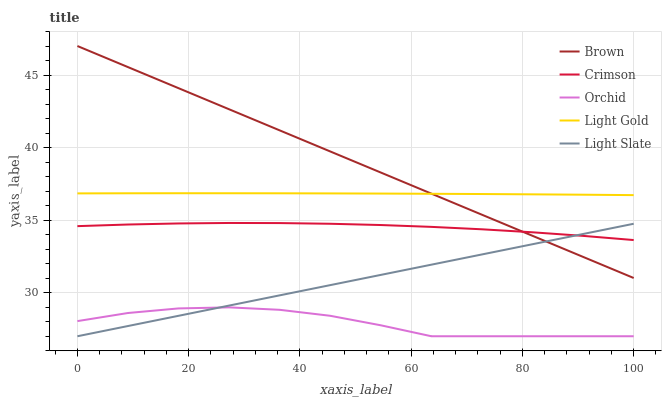Does Orchid have the minimum area under the curve?
Answer yes or no. Yes. Does Brown have the maximum area under the curve?
Answer yes or no. Yes. Does Light Gold have the minimum area under the curve?
Answer yes or no. No. Does Light Gold have the maximum area under the curve?
Answer yes or no. No. Is Light Slate the smoothest?
Answer yes or no. Yes. Is Orchid the roughest?
Answer yes or no. Yes. Is Brown the smoothest?
Answer yes or no. No. Is Brown the roughest?
Answer yes or no. No. Does Light Slate have the lowest value?
Answer yes or no. Yes. Does Brown have the lowest value?
Answer yes or no. No. Does Brown have the highest value?
Answer yes or no. Yes. Does Light Gold have the highest value?
Answer yes or no. No. Is Orchid less than Crimson?
Answer yes or no. Yes. Is Light Gold greater than Crimson?
Answer yes or no. Yes. Does Light Slate intersect Orchid?
Answer yes or no. Yes. Is Light Slate less than Orchid?
Answer yes or no. No. Is Light Slate greater than Orchid?
Answer yes or no. No. Does Orchid intersect Crimson?
Answer yes or no. No. 